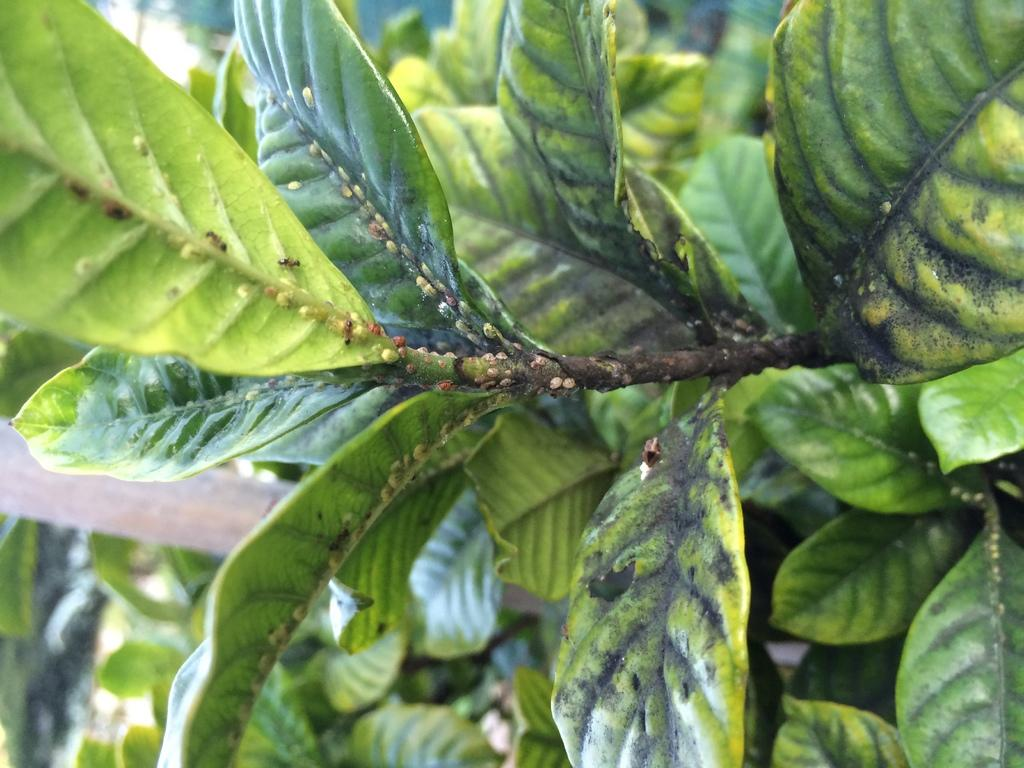What type of living organisms can be seen in the image? Plants can be seen in the image. What other objects or structures are present in the image? There is a pole in the image. How much money is being exchanged between the servant and the plant in the image? There is no servant or exchange of money present in the image; it features plants and a pole. 